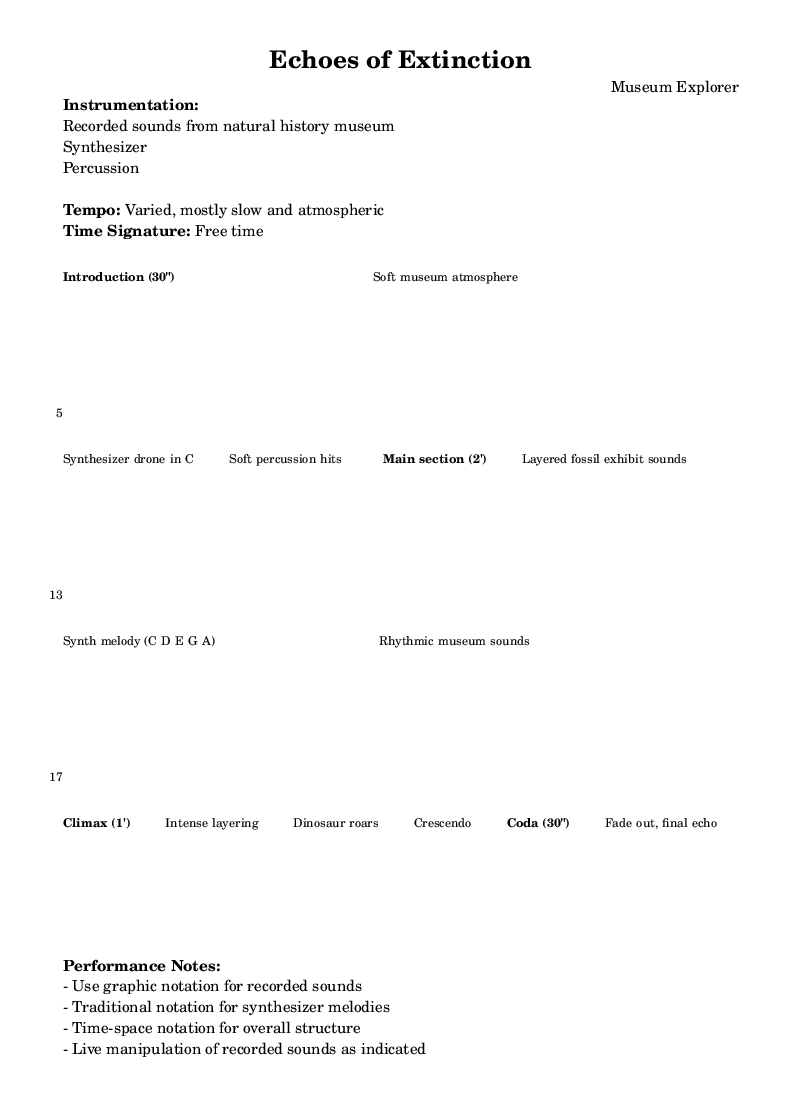What is the title of this piece? The title is specifically mentioned in the header section of the music sheet, where it is clearly stated as "Echoes of Extinction."
Answer: Echoes of Extinction What is the tempo of this composition? The tempo is defined in the markings of the music sheet, which states "Varied, mostly slow and atmospheric." This indicates that there is no strict tempo but a general character to be followed.
Answer: Varied, mostly slow and atmospheric What is the primary instrumentation used in this piece? The instrumentation is listed under "Instrumentation" in the markup section. It specifies that the sounds were recorded from a natural history museum, combined with synthesizer and percussion.
Answer: Recorded sounds from natural history museum, Synthesizer, Percussion How long is the climax section of the composition? The duration of the climax section is stated in the lyrics. It specifies that the climax lasts for "1'." This numeral indicates a duration of one minute, hence revealing the timing of this particular section.
Answer: 1' What kind of notation is suggested for the recorded sounds? There is a performance note that advises the use of graphic notation for recorded sounds, highlighting that this form of notation applies specifically to how sounds are expressed and manipulated in the piece.
Answer: Graphic notation What is the function of the "Coda" in this piece? The coda section is described as "Fade out, final echo," indicating its role in concluding the piece. It suggests a return to a softer sound and an ending that resonates with the audience.
Answer: Fade out, final echo What is the time signature used in this composition? The time signature reflects the need for flexibility and is noted as "Free time." This means there isn't a conventional time signature applied, enabling performers to interpret the rhythm freely.
Answer: Free time 